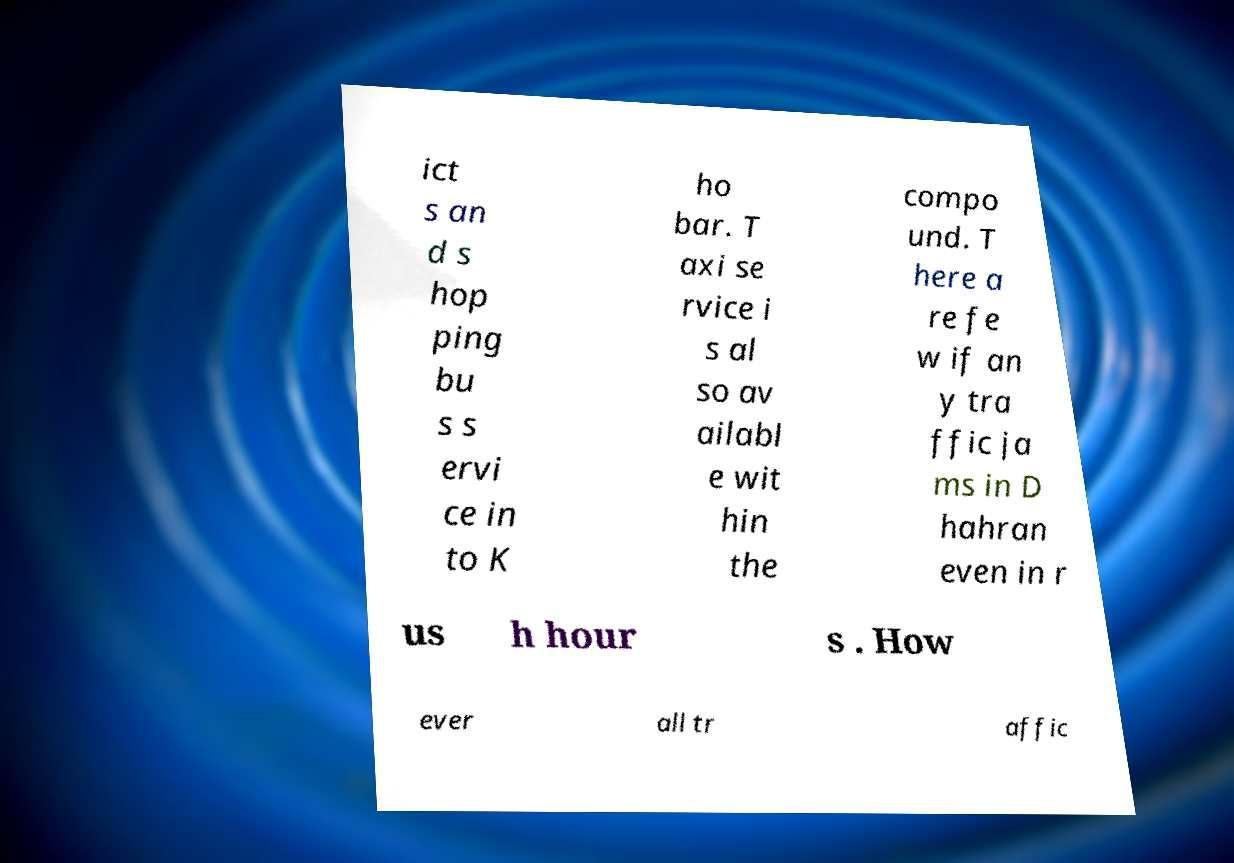For documentation purposes, I need the text within this image transcribed. Could you provide that? ict s an d s hop ping bu s s ervi ce in to K ho bar. T axi se rvice i s al so av ailabl e wit hin the compo und. T here a re fe w if an y tra ffic ja ms in D hahran even in r us h hour s . How ever all tr affic 